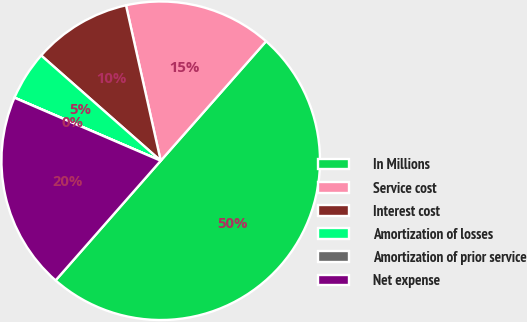<chart> <loc_0><loc_0><loc_500><loc_500><pie_chart><fcel>In Millions<fcel>Service cost<fcel>Interest cost<fcel>Amortization of losses<fcel>Amortization of prior service<fcel>Net expense<nl><fcel>49.97%<fcel>15.0%<fcel>10.01%<fcel>5.01%<fcel>0.01%<fcel>20.0%<nl></chart> 